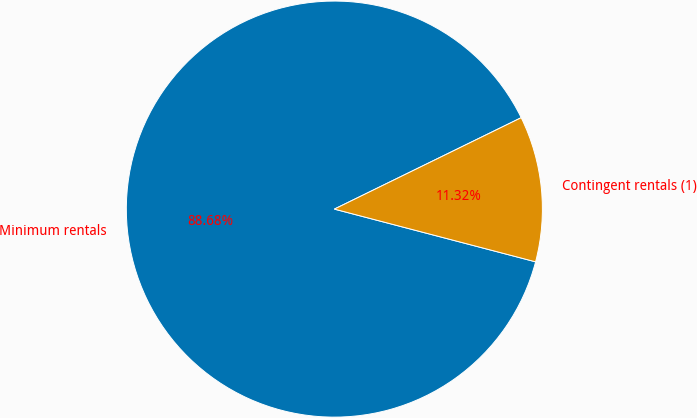Convert chart to OTSL. <chart><loc_0><loc_0><loc_500><loc_500><pie_chart><fcel>Minimum rentals<fcel>Contingent rentals (1)<nl><fcel>88.68%<fcel>11.32%<nl></chart> 